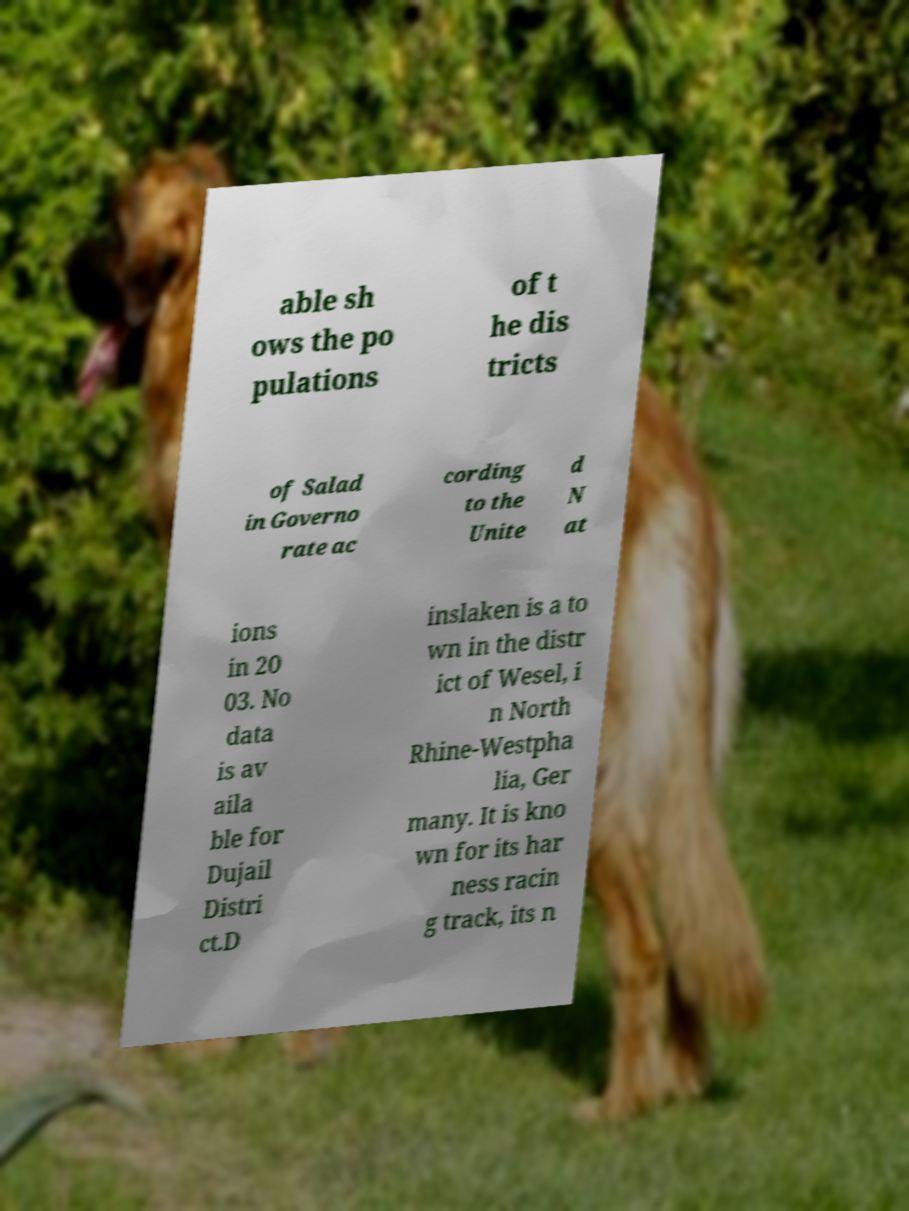Can you read and provide the text displayed in the image?This photo seems to have some interesting text. Can you extract and type it out for me? able sh ows the po pulations of t he dis tricts of Salad in Governo rate ac cording to the Unite d N at ions in 20 03. No data is av aila ble for Dujail Distri ct.D inslaken is a to wn in the distr ict of Wesel, i n North Rhine-Westpha lia, Ger many. It is kno wn for its har ness racin g track, its n 